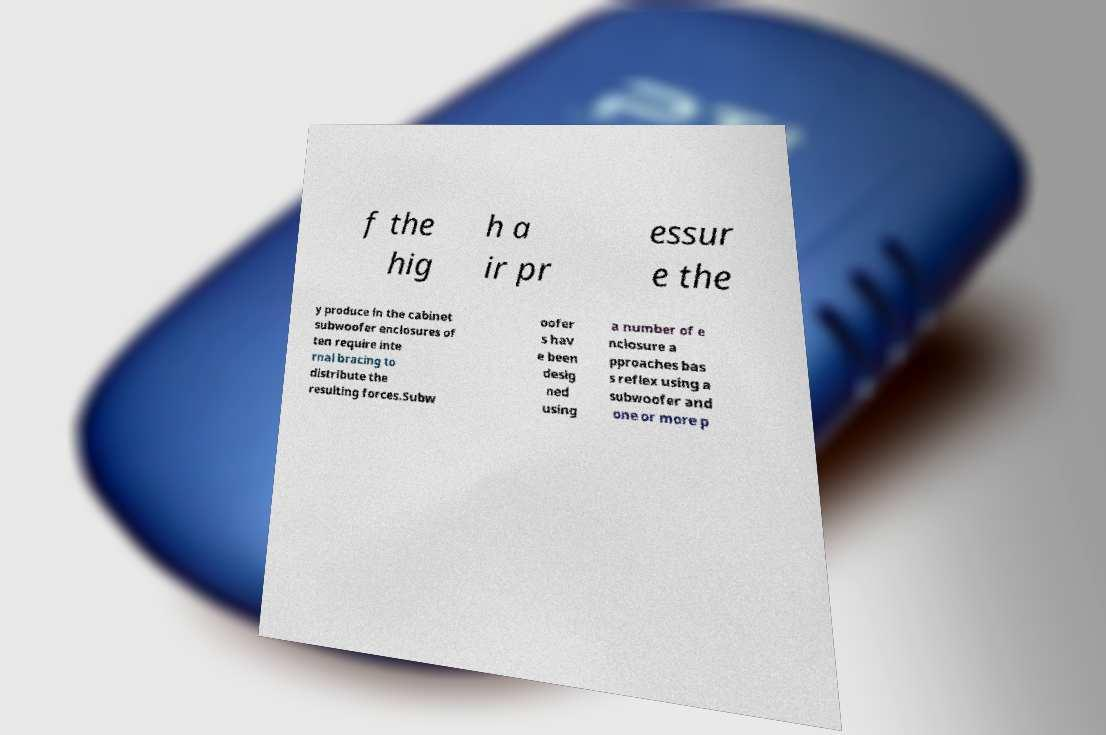Could you assist in decoding the text presented in this image and type it out clearly? f the hig h a ir pr essur e the y produce in the cabinet subwoofer enclosures of ten require inte rnal bracing to distribute the resulting forces.Subw oofer s hav e been desig ned using a number of e nclosure a pproaches bas s reflex using a subwoofer and one or more p 